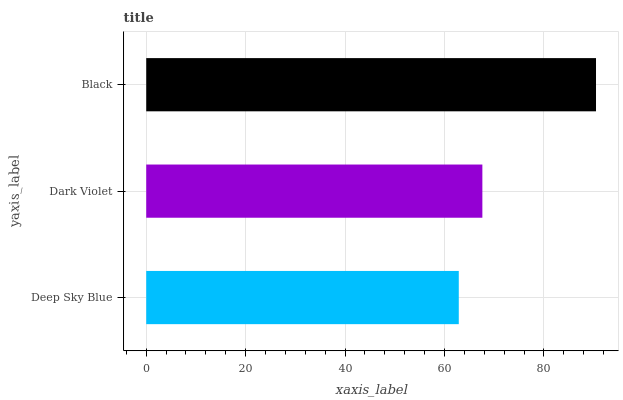Is Deep Sky Blue the minimum?
Answer yes or no. Yes. Is Black the maximum?
Answer yes or no. Yes. Is Dark Violet the minimum?
Answer yes or no. No. Is Dark Violet the maximum?
Answer yes or no. No. Is Dark Violet greater than Deep Sky Blue?
Answer yes or no. Yes. Is Deep Sky Blue less than Dark Violet?
Answer yes or no. Yes. Is Deep Sky Blue greater than Dark Violet?
Answer yes or no. No. Is Dark Violet less than Deep Sky Blue?
Answer yes or no. No. Is Dark Violet the high median?
Answer yes or no. Yes. Is Dark Violet the low median?
Answer yes or no. Yes. Is Black the high median?
Answer yes or no. No. Is Deep Sky Blue the low median?
Answer yes or no. No. 